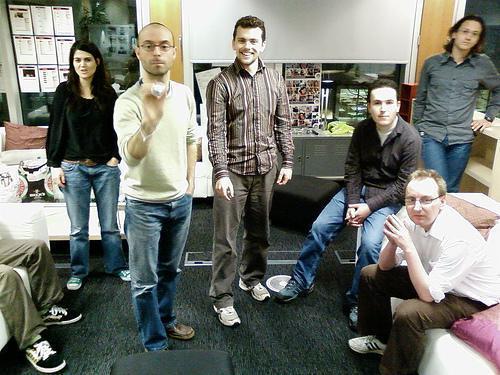How many people are sitting down?
Give a very brief answer. 3. How many people are standing up?
Give a very brief answer. 4. How many people total are in the picture?
Give a very brief answer. 7. How many dinosaurs are in the picture?
Give a very brief answer. 0. How many people are eating?
Give a very brief answer. 0. 